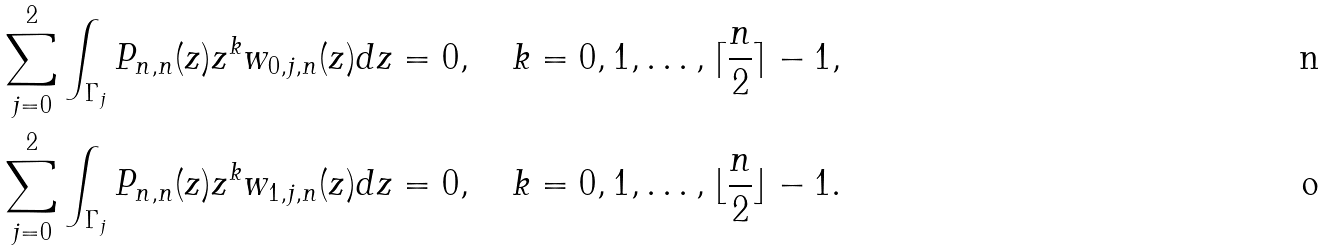Convert formula to latex. <formula><loc_0><loc_0><loc_500><loc_500>\sum _ { j = 0 } ^ { 2 } \int _ { \Gamma _ { j } } P _ { n , n } ( z ) z ^ { k } w _ { 0 , j , n } ( z ) d z & = 0 , \quad k = 0 , 1 , \dots , \lceil \frac { n } { 2 } \rceil - 1 , \\ \sum _ { j = 0 } ^ { 2 } \int _ { \Gamma _ { j } } P _ { n , n } ( z ) z ^ { k } w _ { 1 , j , n } ( z ) d z & = 0 , \quad k = 0 , 1 , \dots , \lfloor \frac { n } { 2 } \rfloor - 1 .</formula> 